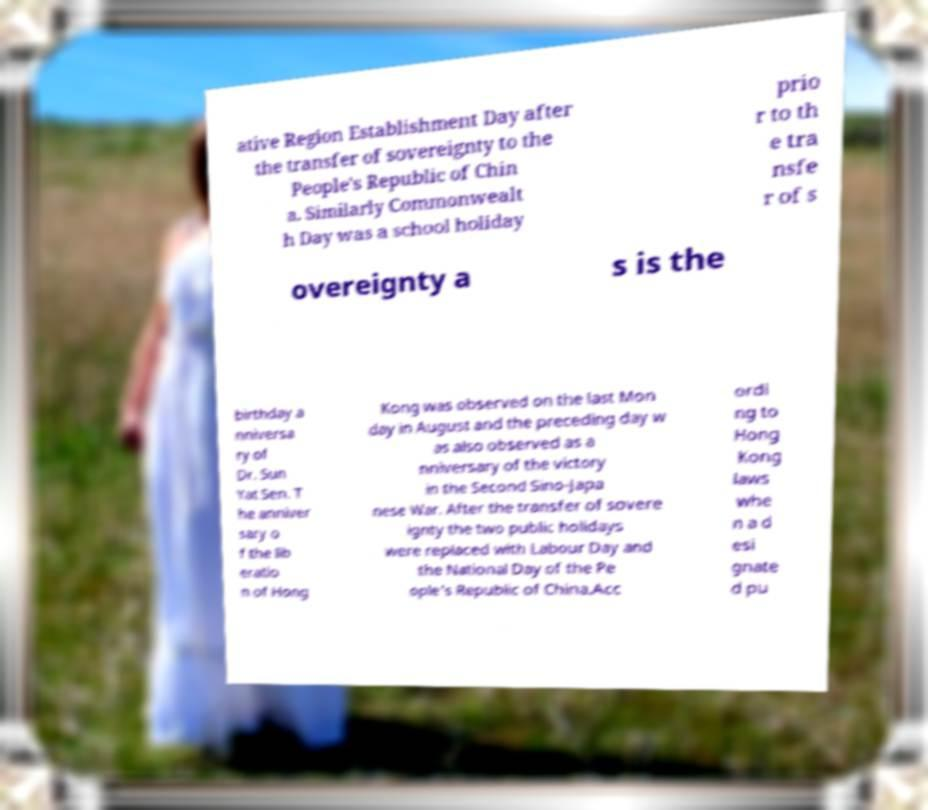What messages or text are displayed in this image? I need them in a readable, typed format. ative Region Establishment Day after the transfer of sovereignty to the People's Republic of Chin a. Similarly Commonwealt h Day was a school holiday prio r to th e tra nsfe r of s overeignty a s is the birthday a nniversa ry of Dr. Sun Yat Sen. T he anniver sary o f the lib eratio n of Hong Kong was observed on the last Mon day in August and the preceding day w as also observed as a nniversary of the victory in the Second Sino-Japa nese War. After the transfer of sovere ignty the two public holidays were replaced with Labour Day and the National Day of the Pe ople's Republic of China.Acc ordi ng to Hong Kong laws whe n a d esi gnate d pu 